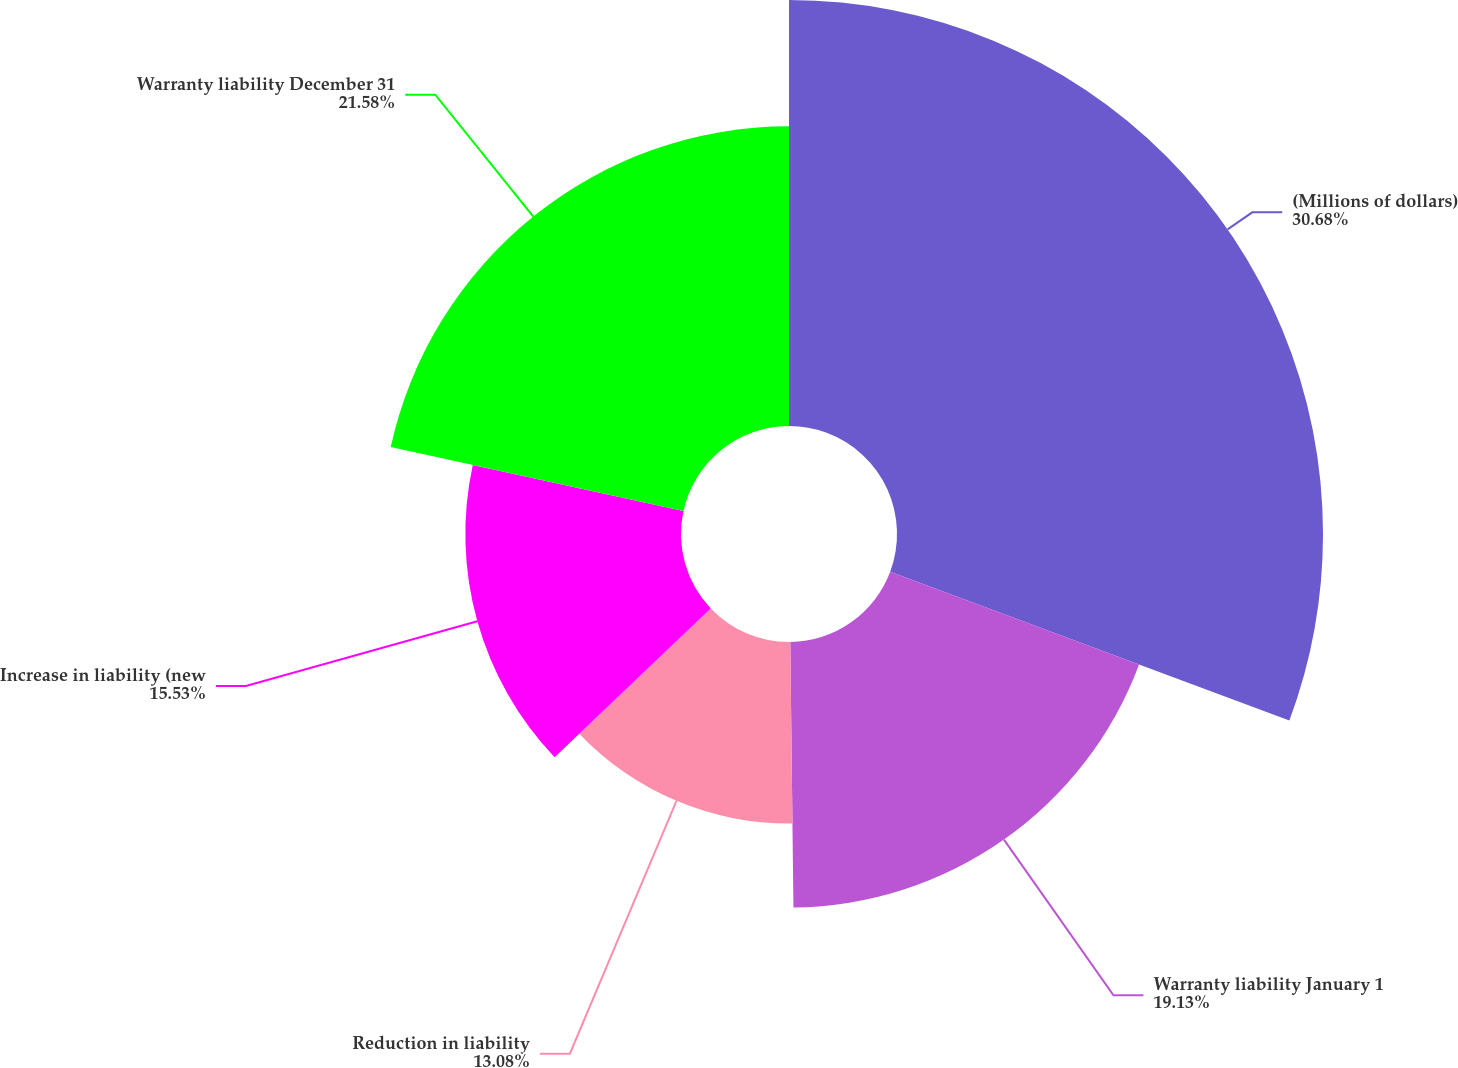<chart> <loc_0><loc_0><loc_500><loc_500><pie_chart><fcel>(Millions of dollars)<fcel>Warranty liability January 1<fcel>Reduction in liability<fcel>Increase in liability (new<fcel>Warranty liability December 31<nl><fcel>30.68%<fcel>19.13%<fcel>13.08%<fcel>15.53%<fcel>21.58%<nl></chart> 